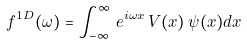Convert formula to latex. <formula><loc_0><loc_0><loc_500><loc_500>f ^ { 1 D } ( \omega ) = \int _ { - \infty } ^ { \infty } \, e ^ { i \omega x } \, V ( x ) \, \psi ( x ) d x</formula> 